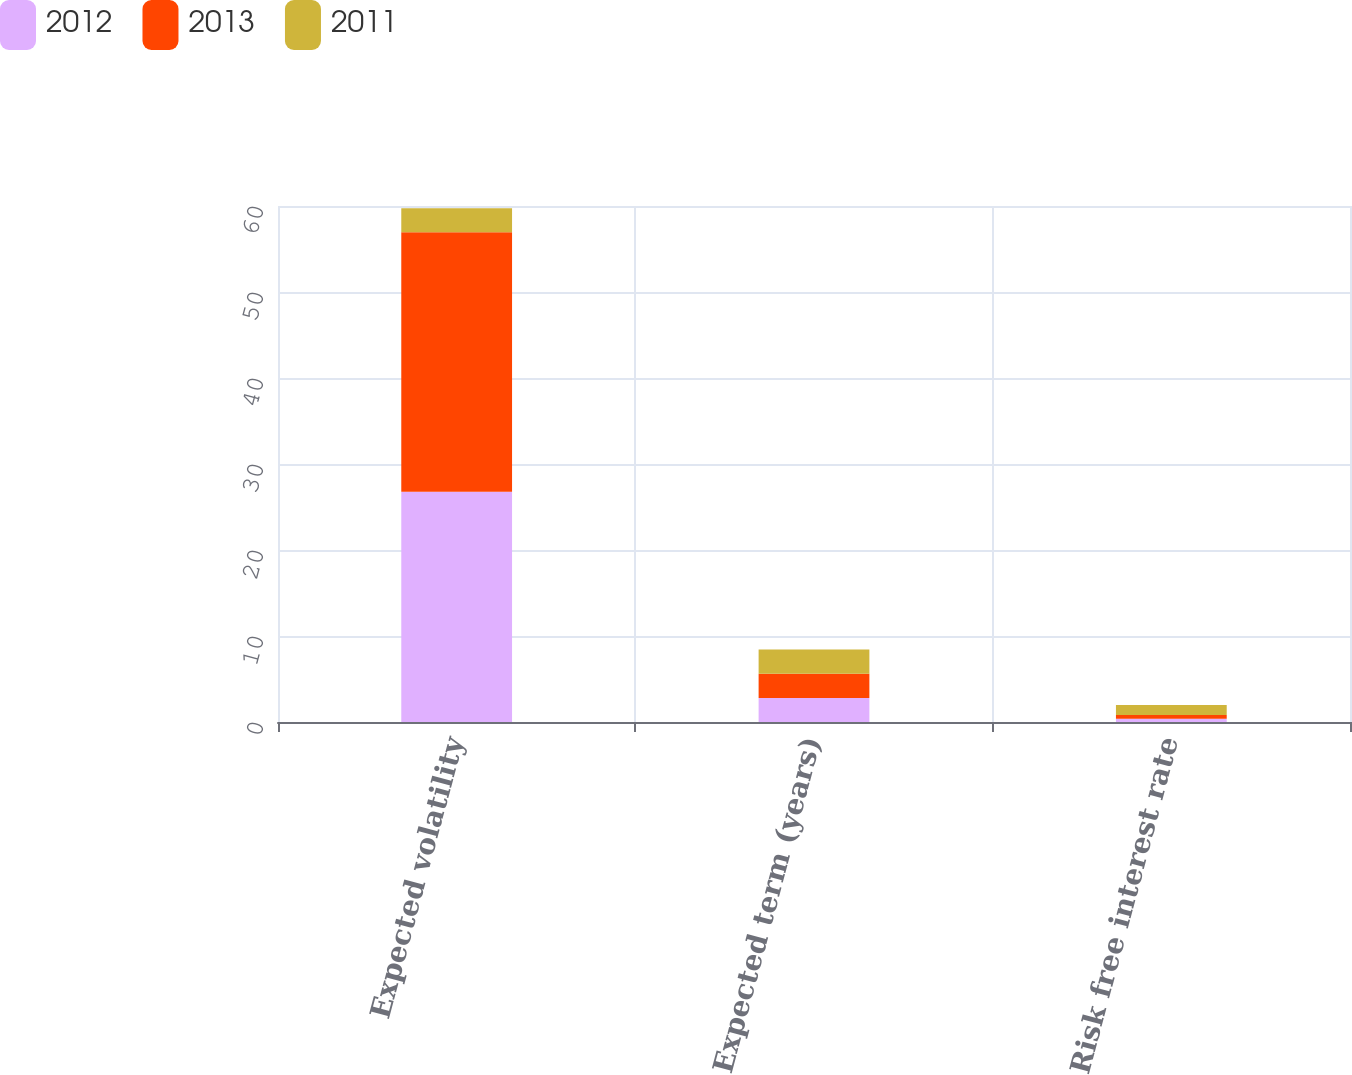Convert chart to OTSL. <chart><loc_0><loc_0><loc_500><loc_500><stacked_bar_chart><ecel><fcel>Expected volatility<fcel>Expected term (years)<fcel>Risk free interest rate<nl><fcel>2012<fcel>26.76<fcel>2.8<fcel>0.39<nl><fcel>2013<fcel>30.18<fcel>2.81<fcel>0.42<nl><fcel>2011<fcel>2.805<fcel>2.81<fcel>1.18<nl></chart> 